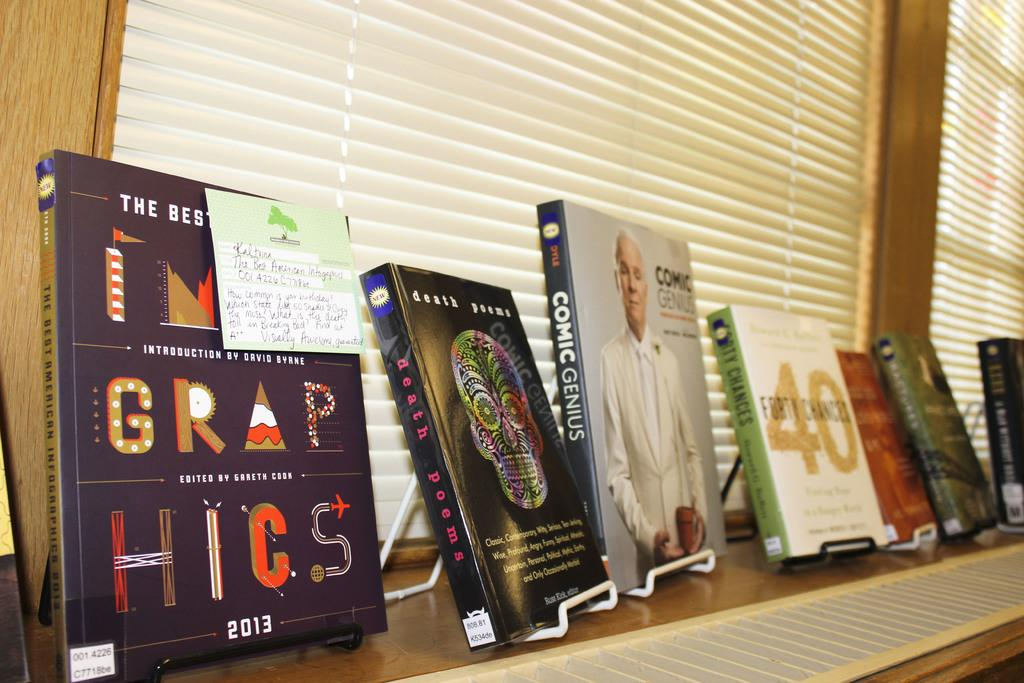<image>
Write a terse but informative summary of the picture. a book that says comic genius on it 